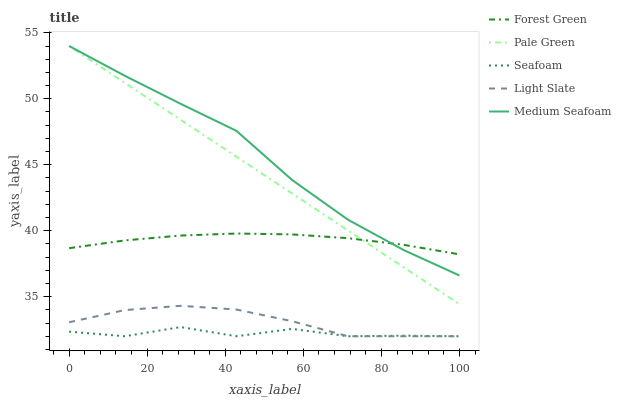Does Seafoam have the minimum area under the curve?
Answer yes or no. Yes. Does Medium Seafoam have the maximum area under the curve?
Answer yes or no. Yes. Does Forest Green have the minimum area under the curve?
Answer yes or no. No. Does Forest Green have the maximum area under the curve?
Answer yes or no. No. Is Pale Green the smoothest?
Answer yes or no. Yes. Is Seafoam the roughest?
Answer yes or no. Yes. Is Forest Green the smoothest?
Answer yes or no. No. Is Forest Green the roughest?
Answer yes or no. No. Does Light Slate have the lowest value?
Answer yes or no. Yes. Does Pale Green have the lowest value?
Answer yes or no. No. Does Medium Seafoam have the highest value?
Answer yes or no. Yes. Does Forest Green have the highest value?
Answer yes or no. No. Is Light Slate less than Forest Green?
Answer yes or no. Yes. Is Forest Green greater than Light Slate?
Answer yes or no. Yes. Does Seafoam intersect Light Slate?
Answer yes or no. Yes. Is Seafoam less than Light Slate?
Answer yes or no. No. Is Seafoam greater than Light Slate?
Answer yes or no. No. Does Light Slate intersect Forest Green?
Answer yes or no. No. 